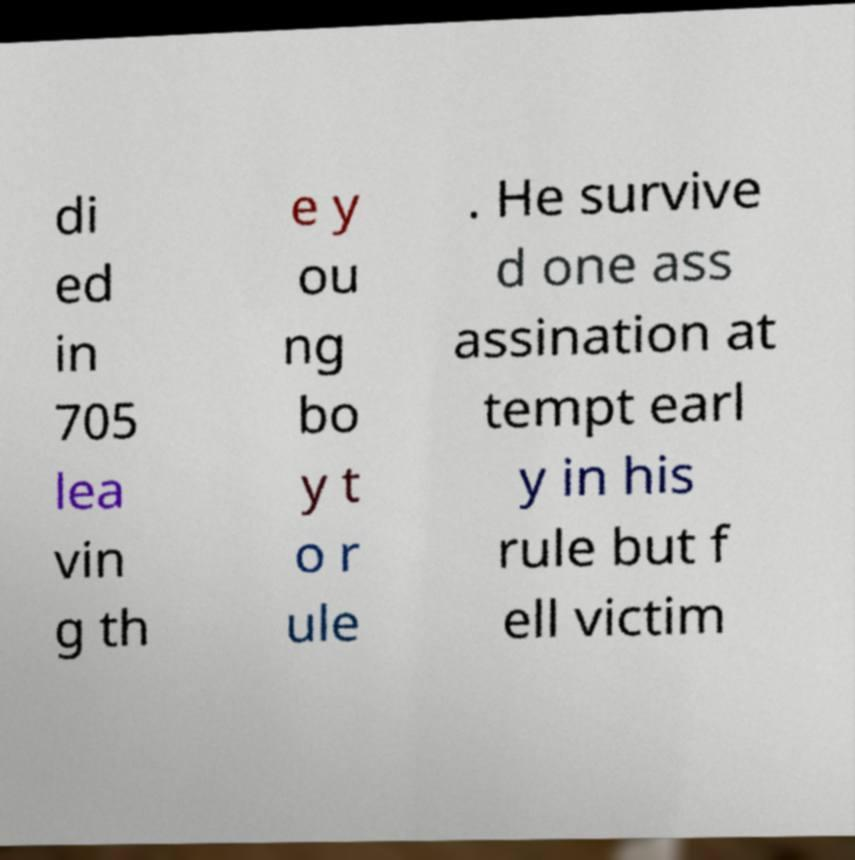Could you extract and type out the text from this image? di ed in 705 lea vin g th e y ou ng bo y t o r ule . He survive d one ass assination at tempt earl y in his rule but f ell victim 